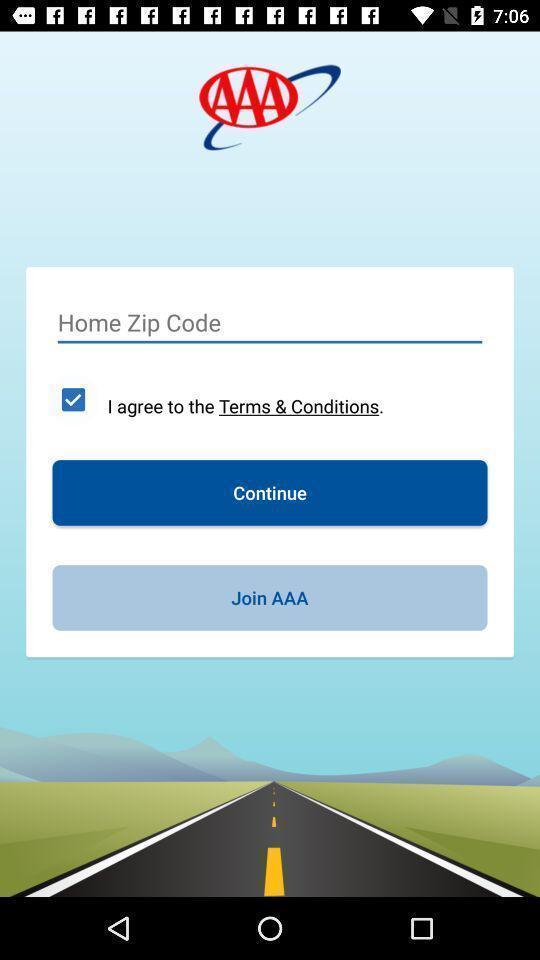Describe the content in this image. Page displaying a text area to enter home zip code. 